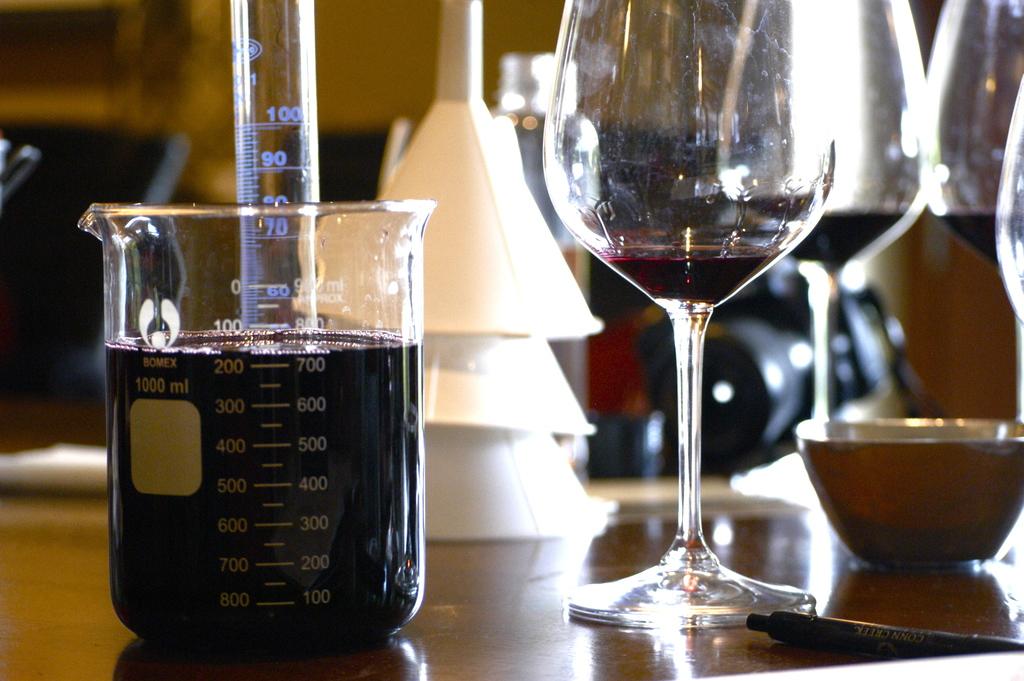What is the top number on the beaker?
Give a very brief answer. 100. How many ml of liquid are in the glass?
Your answer should be compact. 700. 